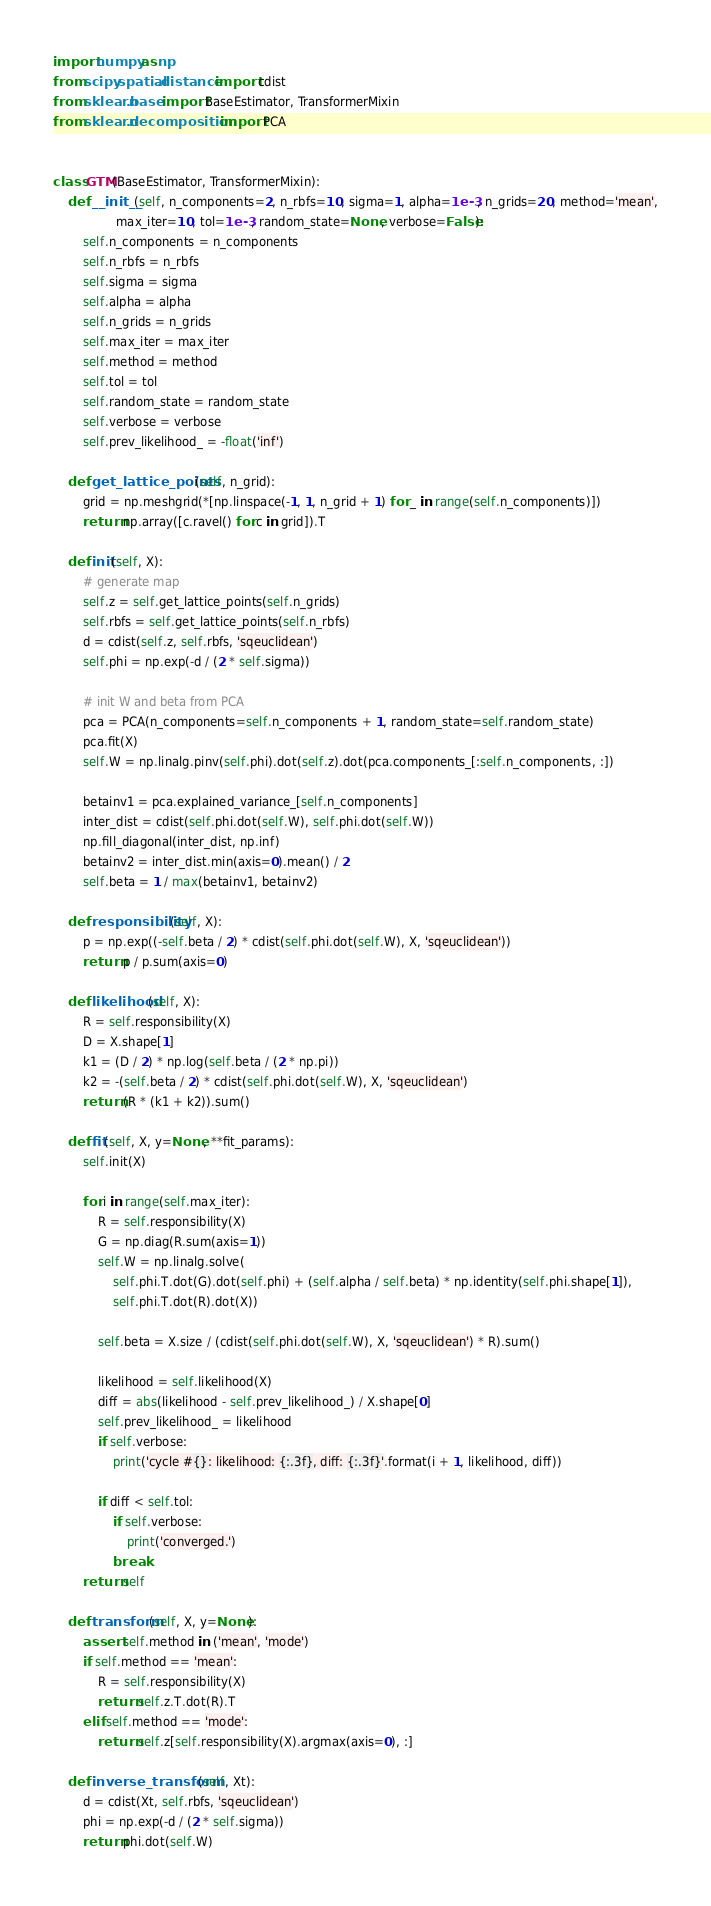Convert code to text. <code><loc_0><loc_0><loc_500><loc_500><_Python_>import numpy as np
from scipy.spatial.distance import cdist
from sklearn.base import BaseEstimator, TransformerMixin
from sklearn.decomposition import PCA


class GTM(BaseEstimator, TransformerMixin):
    def __init__(self, n_components=2, n_rbfs=10, sigma=1, alpha=1e-3, n_grids=20, method='mean',
                 max_iter=10, tol=1e-3, random_state=None, verbose=False):
        self.n_components = n_components
        self.n_rbfs = n_rbfs
        self.sigma = sigma
        self.alpha = alpha
        self.n_grids = n_grids
        self.max_iter = max_iter
        self.method = method
        self.tol = tol
        self.random_state = random_state
        self.verbose = verbose
        self.prev_likelihood_ = -float('inf')
    
    def get_lattice_points(self, n_grid):
        grid = np.meshgrid(*[np.linspace(-1, 1, n_grid + 1) for _ in range(self.n_components)])
        return np.array([c.ravel() for c in grid]).T
    
    def init(self, X):
        # generate map
        self.z = self.get_lattice_points(self.n_grids)
        self.rbfs = self.get_lattice_points(self.n_rbfs)
        d = cdist(self.z, self.rbfs, 'sqeuclidean')
        self.phi = np.exp(-d / (2 * self.sigma))
        
        # init W and beta from PCA
        pca = PCA(n_components=self.n_components + 1, random_state=self.random_state)
        pca.fit(X)
        self.W = np.linalg.pinv(self.phi).dot(self.z).dot(pca.components_[:self.n_components, :])
        
        betainv1 = pca.explained_variance_[self.n_components]
        inter_dist = cdist(self.phi.dot(self.W), self.phi.dot(self.W))
        np.fill_diagonal(inter_dist, np.inf)
        betainv2 = inter_dist.min(axis=0).mean() / 2
        self.beta = 1 / max(betainv1, betainv2)
    
    def responsibility(self, X):
        p = np.exp((-self.beta / 2) * cdist(self.phi.dot(self.W), X, 'sqeuclidean'))
        return p / p.sum(axis=0)
    
    def likelihood(self, X):
        R = self.responsibility(X)
        D = X.shape[1]
        k1 = (D / 2) * np.log(self.beta / (2 * np.pi))
        k2 = -(self.beta / 2) * cdist(self.phi.dot(self.W), X, 'sqeuclidean')
        return (R * (k1 + k2)).sum()
    
    def fit(self, X, y=None, **fit_params):
        self.init(X)
        
        for i in range(self.max_iter):
            R = self.responsibility(X)
            G = np.diag(R.sum(axis=1))
            self.W = np.linalg.solve(
                self.phi.T.dot(G).dot(self.phi) + (self.alpha / self.beta) * np.identity(self.phi.shape[1]),
                self.phi.T.dot(R).dot(X))
            
            self.beta = X.size / (cdist(self.phi.dot(self.W), X, 'sqeuclidean') * R).sum()
            
            likelihood = self.likelihood(X)
            diff = abs(likelihood - self.prev_likelihood_) / X.shape[0]
            self.prev_likelihood_ = likelihood
            if self.verbose:
                print('cycle #{}: likelihood: {:.3f}, diff: {:.3f}'.format(i + 1, likelihood, diff))
            
            if diff < self.tol:
                if self.verbose:
                    print('converged.')
                break
        return self
    
    def transform(self, X, y=None):
        assert self.method in ('mean', 'mode')
        if self.method == 'mean':
            R = self.responsibility(X)
            return self.z.T.dot(R).T
        elif self.method == 'mode':
            return self.z[self.responsibility(X).argmax(axis=0), :]
    
    def inverse_transform(self, Xt):
        d = cdist(Xt, self.rbfs, 'sqeuclidean')
        phi = np.exp(-d / (2 * self.sigma))
        return phi.dot(self.W)
</code> 